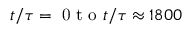Convert formula to latex. <formula><loc_0><loc_0><loc_500><loc_500>t / \tau = 0 t o t / \tau \approx 1 8 0 0</formula> 